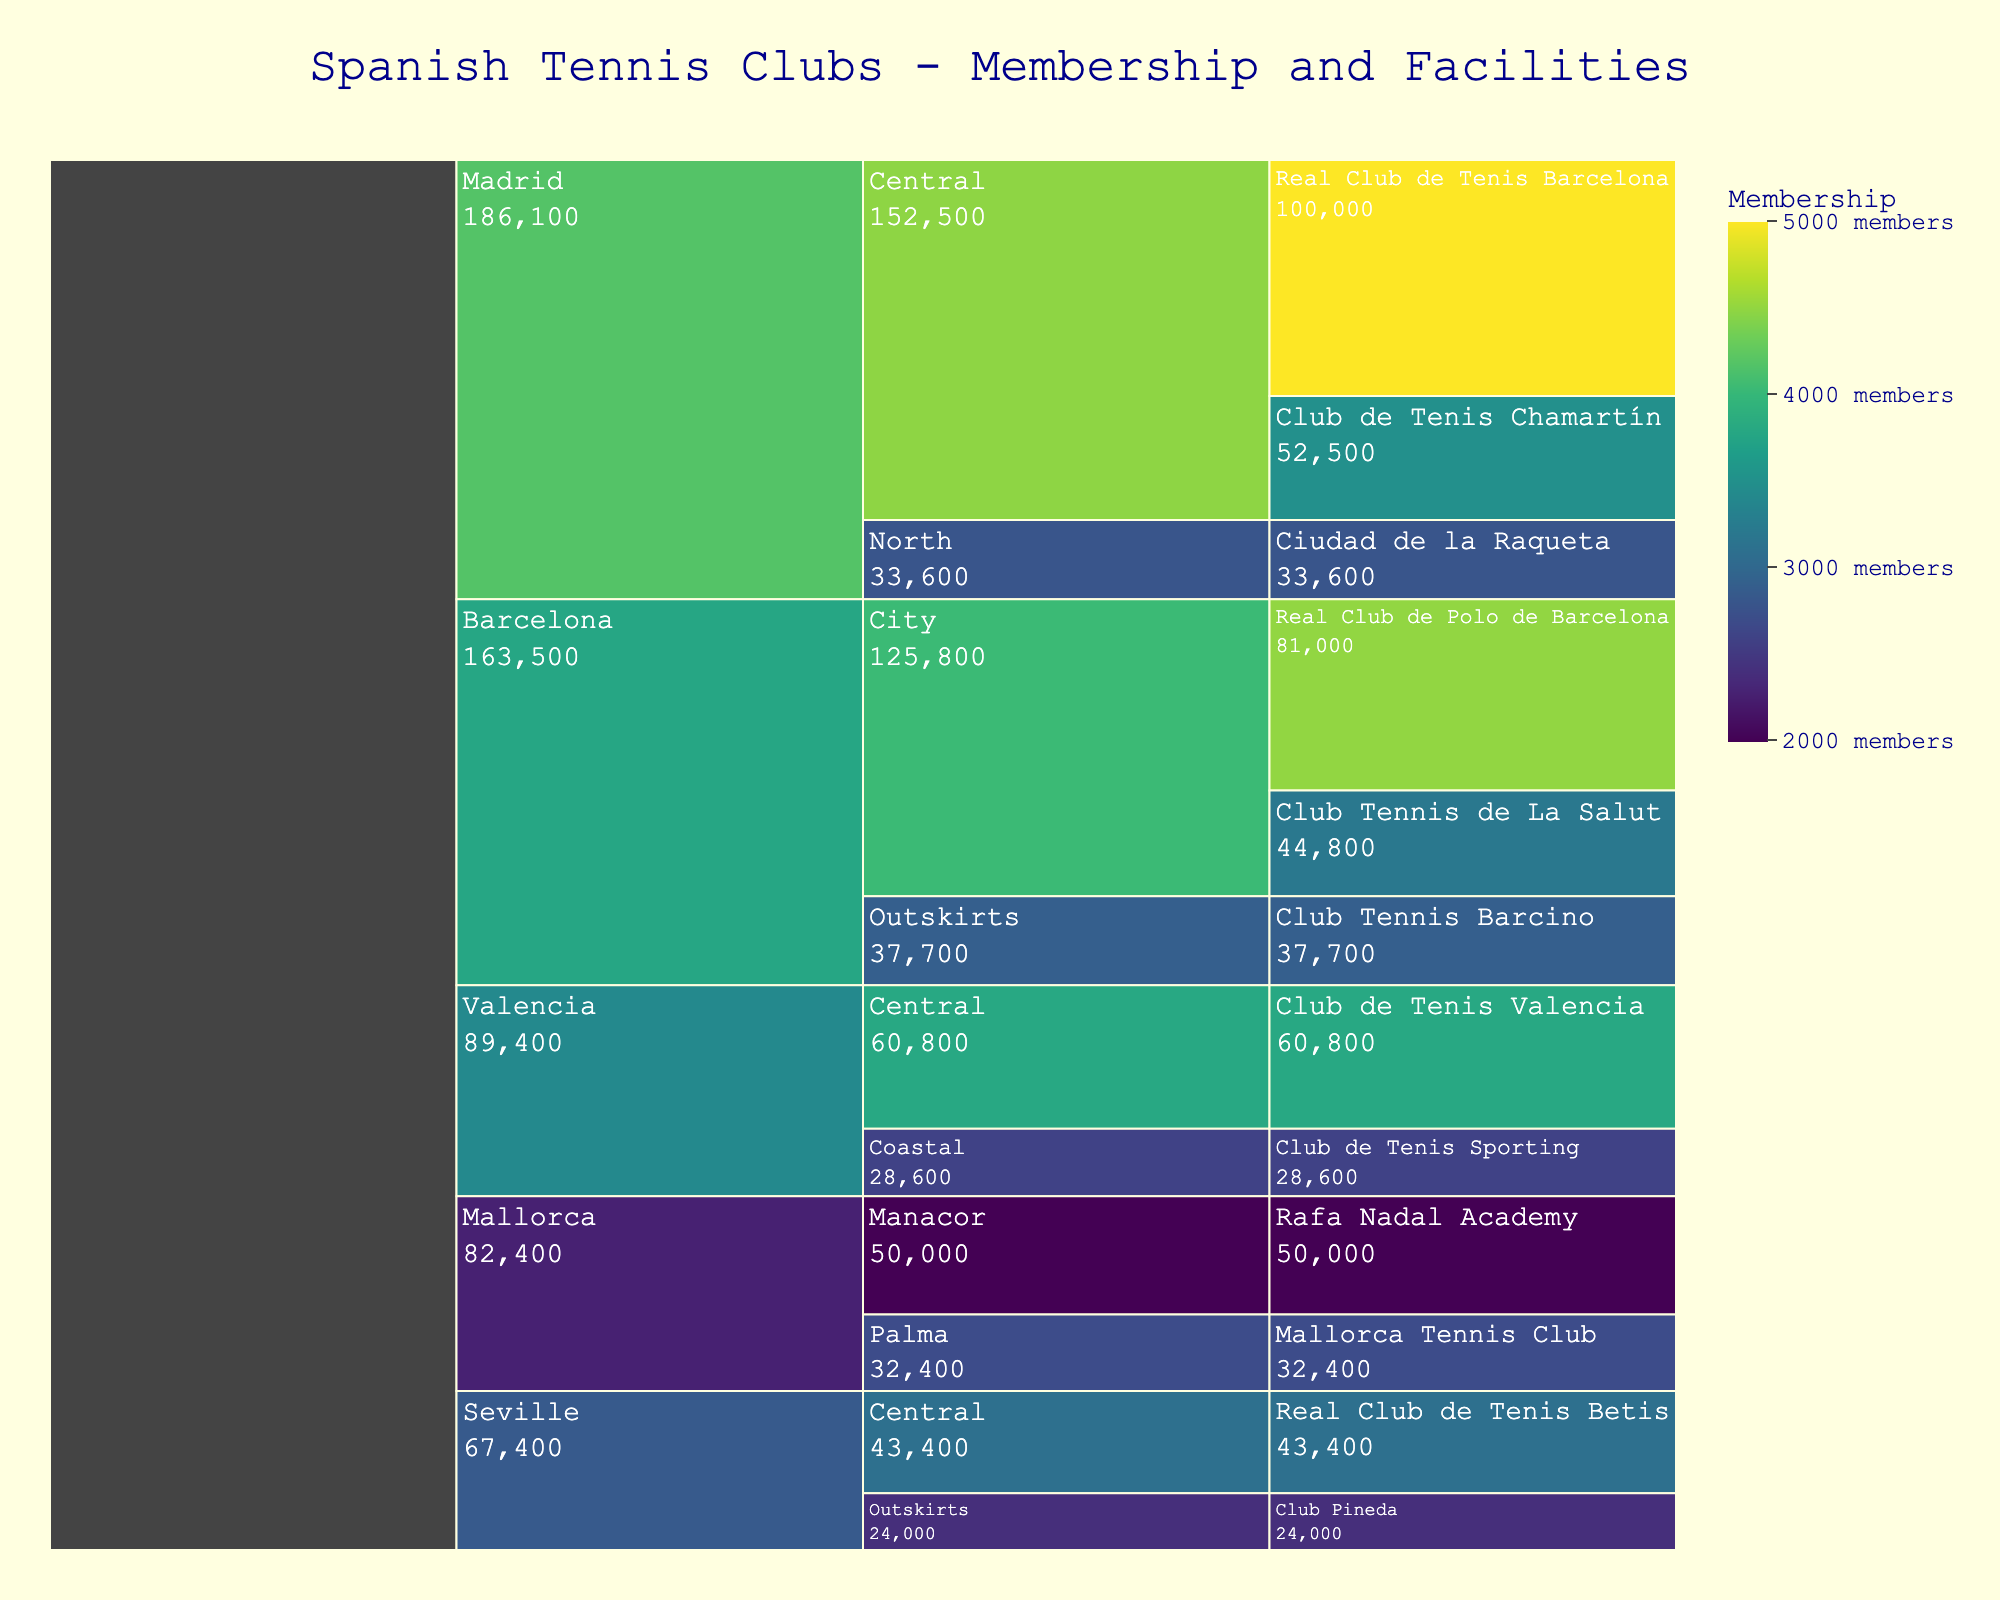What's the title of the chart? The title is typically placed at the top of the chart. From the data input, the title should be identified from the code.
Answer: Spanish Tennis Clubs - Membership and Facilities Which club has the highest membership? The club with the highest membership will be the darkest green color in the chart, as darker colors represent higher membership. Referring to the data, Real Club de Tenis Barcelona has the highest membership.
Answer: Real Club de Tenis Barcelona How many clubs are in the Central subcategory of Madrid? In the chart, you can identify subcategories and count the number of branches under the 'Central' subcategory within 'Madrid'. By referencing the data, there are two clubs: Real Club de Tenis Barcelona and Club de Tenis Chamartín.
Answer: 2 Which subcategory has the lowest total value (membership * facilities) in Barcelona? Total value can be calculated by multiplying membership and facilities for each club within the subcategory. 
For City: (4500*18 + 3200*14) = 94800
For Outskirts: (2900*13) = 37700
Outskirts have the lowest value.
Answer: Outskirts Which club has more facilities: Ciudad de la Raqueta or Mallorca Tennis Club? Compare the number of facilities directly from the data or chart.
Ciudad de la Raqueta: 12
Mallorca Tennis Club: 12
Both clubs have the same number of facilities.
Answer: Both have the same What’s the average membership in the Valencia region? Average membership is calculated by summing the membership values for clubs in Valencia and dividing by the number of clubs.
(3800 + 2600) / 2 = 3200
Answer: 3200 Among the Central subcategories, which region (Madrid or Valencia) has a higher total value? Calculate total value for Central clubs in each region:
Madrid: (5000*20 + 3500*15) = 175000
Valencia: (3800*16) = 60800
Madrid has a higher total value.
Answer: Madrid In Seville, which club has fewer facilities: Real Club de Tenis Betis or Club Pineda? Compare the facility counts directly from the figure or data.
Real Club de Tenis Betis: 14
Club Pineda: 10
Club Pineda has fewer facilities.
Answer: Club Pineda What subcategory has the highest average value in Madrid? Calculate the average value for Central and North:
Central: (5000*20 + 3500*15) / 2 = 87500
North: (2800*12) = 33600
Central has the highest average value.
Answer: Central 